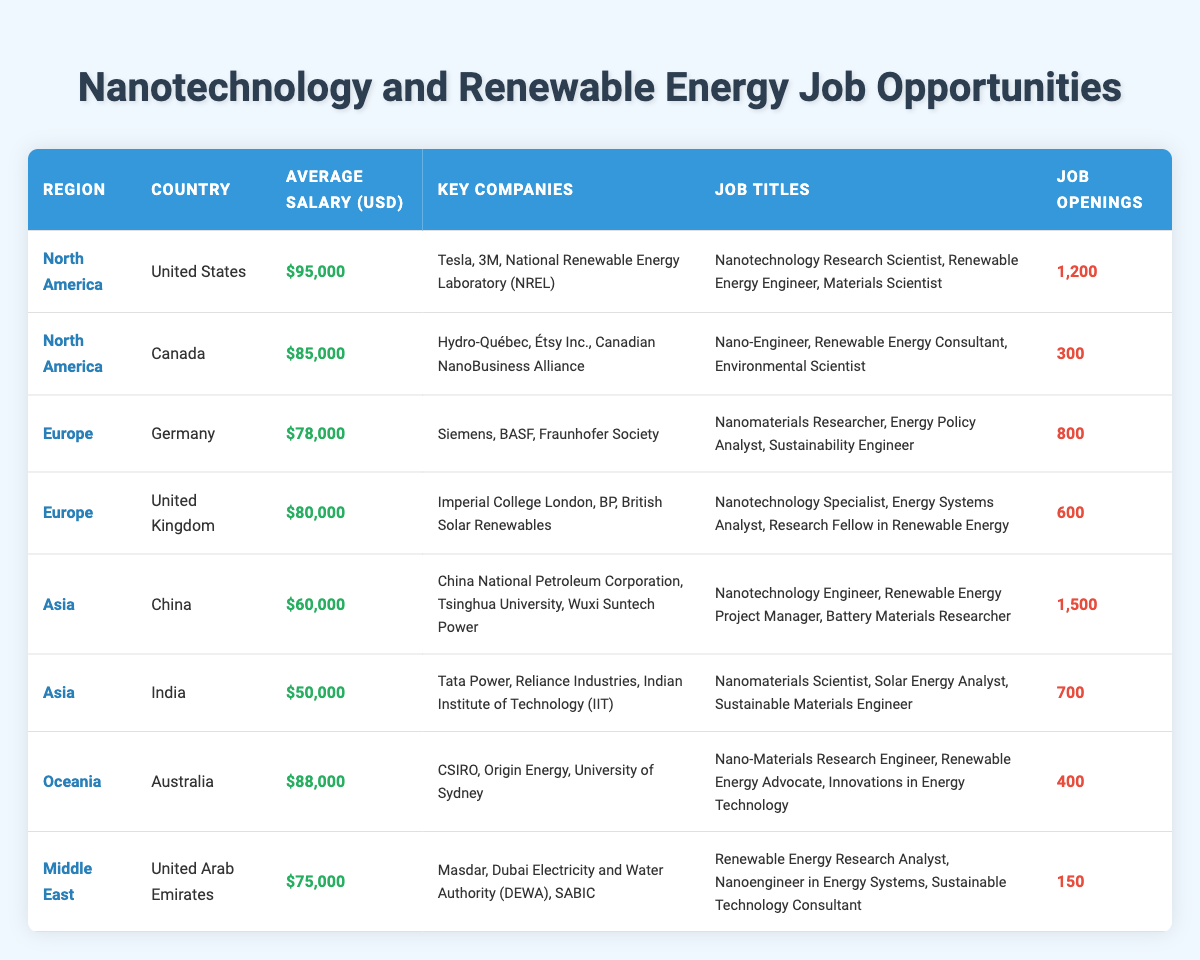What is the average salary for job opportunities in North America? The job opportunities in North America include data from the United States ($95,000) and Canada ($85,000). To find the average salary, sum these values: $95,000 + $85,000 = $180,000. Then divide by 2: $180,000 / 2 = $90,000.
Answer: $90,000 Which country has the most job openings in the nanotechnology and renewable energy sectors? According to the table, China has the highest number of job openings at 1,500. Other countries have lower job openings, with the next highest being the United States with 1,200 openings.
Answer: China Is the average salary in Germany higher than in the United Arab Emirates? The average salary in Germany is $78,000, while in the United Arab Emirates it is $75,000. Since $78,000 is greater than $75,000, the answer is yes.
Answer: Yes How many total job openings are there in the Asia region? In the Asia region, China has 1,500 job openings and India has 700 job openings. To find the total, add these two numbers: 1,500 + 700 = 2,200.
Answer: 2,200 Are there job openings for Renewable Energy Consultants in Canada? Yes, according to the table, Canada lists the job title "Renewable Energy Consultant" as one of the available positions.
Answer: Yes What is the difference in average salary between Australia and India? Australia has an average salary of $88,000 and India has an average salary of $50,000. To find the difference, subtract India's salary from Australia's: $88,000 - $50,000 = $38,000.
Answer: $38,000 Which country has the fewest job openings, and how many are there? The country with the fewest job openings is the United Arab Emirates, which has 150 openings.
Answer: United Arab Emirates, 150 What is the average salary of job opportunities in Europe? The average salaries in Europe are $78,000 (Germany) and $80,000 (United Kingdom). Sum these values: $78,000 + $80,000 = $158,000. Divide by 2 to find the average: $158,000 / 2 = $79,000.
Answer: $79,000 Is there a job title listed for a Sustainable Technology Consultant in the table? Yes, the job title for a Sustainable Technology Consultant is listed under job opportunities in the United Arab Emirates.
Answer: Yes 